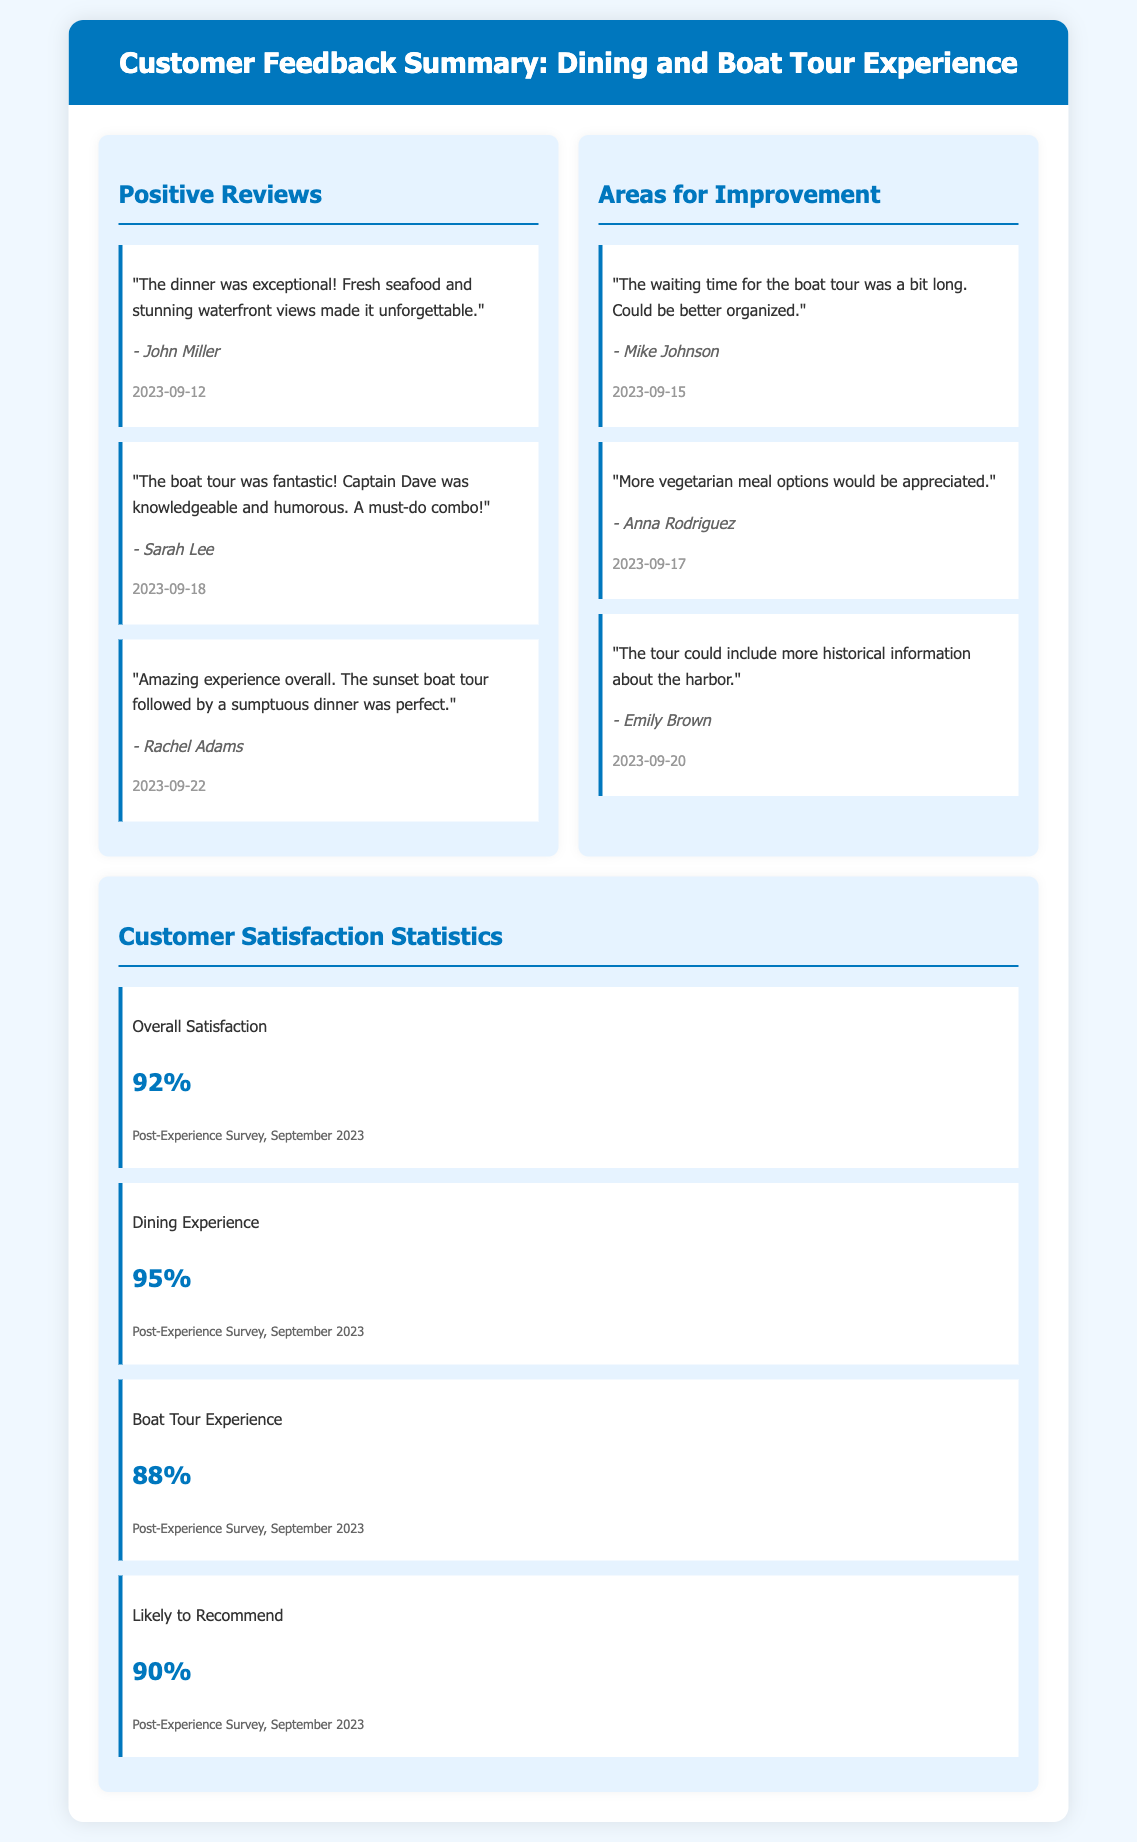What is the date of John's review? John Miller left his review on September 12, 2023.
Answer: 2023-09-12 What percentage of customers were satisfied with the overall experience? The overall satisfaction rate provided in the statistics section is 92%.
Answer: 92% Who mentioned the need for more vegetarian meal options? Anna Rodriguez pointed out the need for more vegetarian options.
Answer: Anna Rodriguez What is the satisfaction percentage for the dining experience? The statistics indicate a satisfaction rate of 95% for the dining experience.
Answer: 95% How many positive reviews are listed in the document? There are three positive reviews highlighted in the document.
Answer: 3 What was the date of Rachel Adams' review? Rachel Adams' review was submitted on September 22, 2023.
Answer: 2023-09-22 What is the satisfaction percentage for the boat tour experience? The boat tour experience satisfaction percentage is 88%.
Answer: 88% What did Mike Johnson mention about the boat tour? Mike Johnson noted that the waiting time for the boat tour was a bit long.
Answer: Waiting time What percentage of customers are likely to recommend the experience? The document states that 90% of customers are likely to recommend the experience.
Answer: 90% 